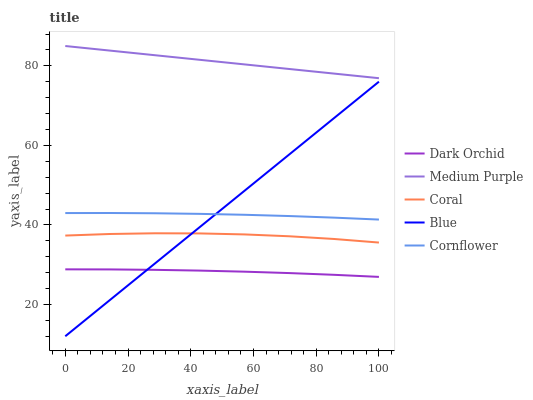Does Blue have the minimum area under the curve?
Answer yes or no. No. Does Blue have the maximum area under the curve?
Answer yes or no. No. Is Blue the smoothest?
Answer yes or no. No. Is Blue the roughest?
Answer yes or no. No. Does Coral have the lowest value?
Answer yes or no. No. Does Blue have the highest value?
Answer yes or no. No. Is Coral less than Cornflower?
Answer yes or no. Yes. Is Cornflower greater than Coral?
Answer yes or no. Yes. Does Coral intersect Cornflower?
Answer yes or no. No. 